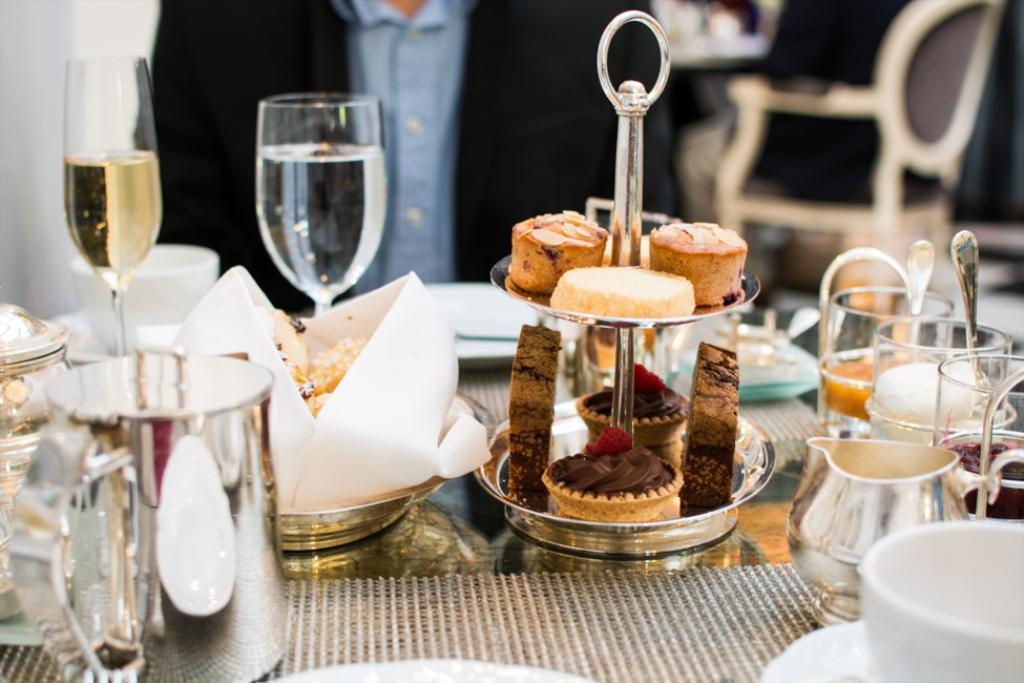How would you summarize this image in a sentence or two? In this image we can see a table with mat. On the table there are glasses, jug, plates with food items and many other things. In the background it is looking blur and there is a person. 